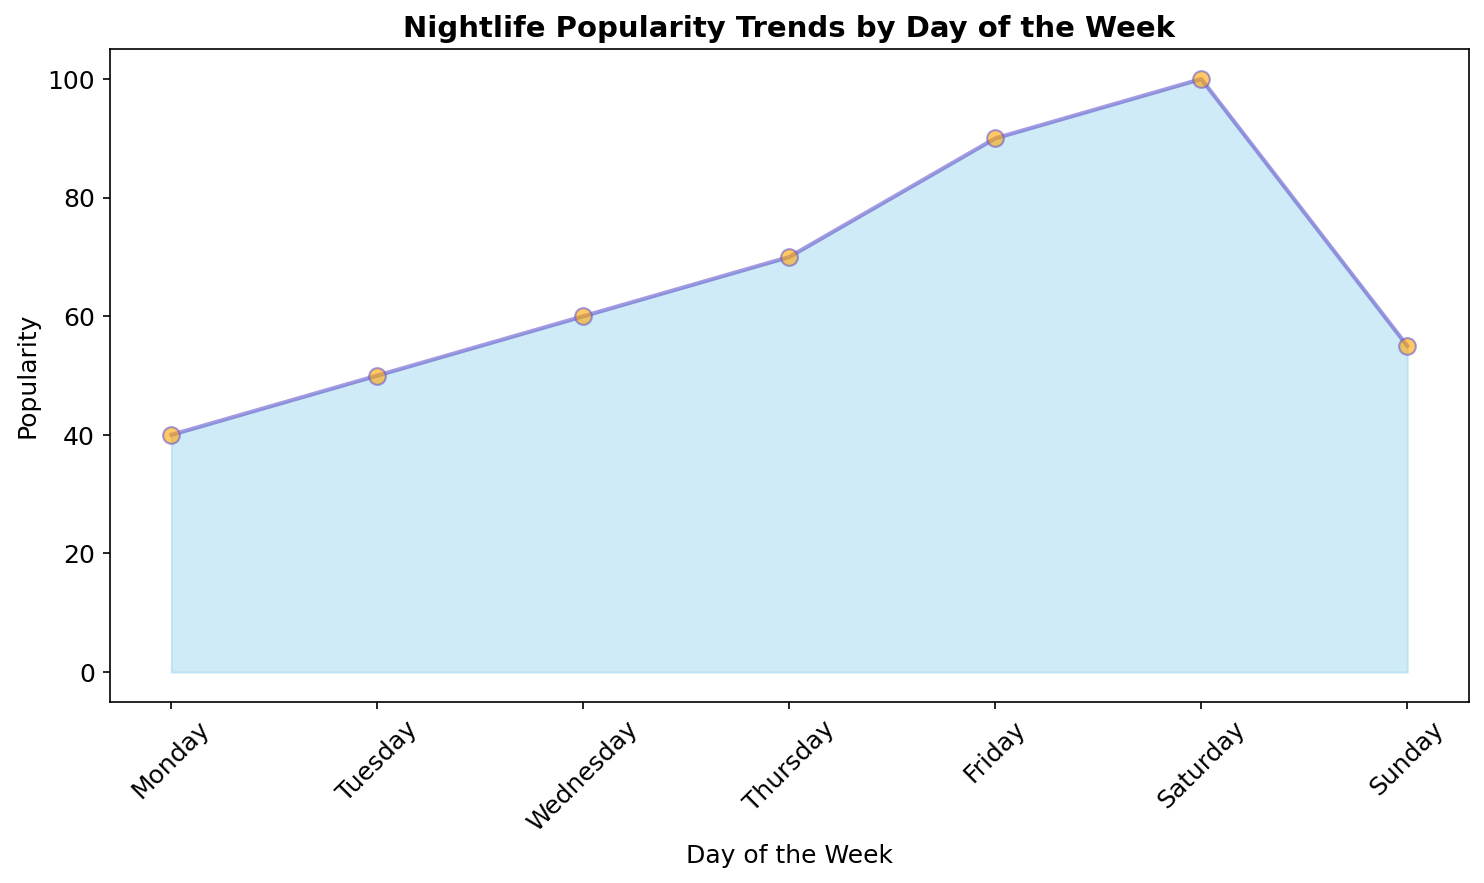Which day shows the peak of nightlife popularity? The highest value on the area chart corresponds to the day with the peak popularity. Saturday has the highest popularity value, which is 100.
Answer: Saturday Which day has the lowest nightlife popularity? The lowest value on the area chart corresponds to the day with the lowest popularity. Monday has the lowest popularity value, which is 40.
Answer: Monday What is the average nightlife popularity from Monday to Wednesday? Add the popularity values of Monday (40), Tuesday (50), and Wednesday (60), then divide by 3. (40 + 50 + 60) / 3 = 150 / 3 = 50
Answer: 50 Is the nightlife popularity on Sunday higher or lower than on Friday? Compare the values of Friday (90) and Sunday (55). Friday's popularity is higher than Sunday's.
Answer: Lower What is the difference in nightlife popularity between the busiest and least busy days? Subtract the lowest popularity value (Monday: 40) from the highest popularity value (Saturday: 100). 100 - 40 = 60
Answer: 60 On which day does nightlife popularity start to increase significantly? Identify the day where the increase in popularity becomes noticeable. From Wednesday (60) to Thursday (70), there is a significant rise, continuing sharply into Friday and Saturday.
Answer: Thursday What is the total nightlife popularity from Thursday to Saturday? Add the popularity values of Thursday (70), Friday (90), and Saturday (100). 70 + 90 + 100 = 260
Answer: 260 Is the popularity on Wednesday closer to Tuesday or Thursday? Compare the differences: Wednesday (60) - Tuesday (50) = 10, and Thursday (70) - Wednesday (60) = 10. The differences are equal, making Wednesday equally distant from both.
Answer: Equally distant Which color indicates the area representing nightlife popularity in the chart? The description indicates the area is filled with 'skyblue' color, representing nightlife popularity visually.
Answer: Sky blue 